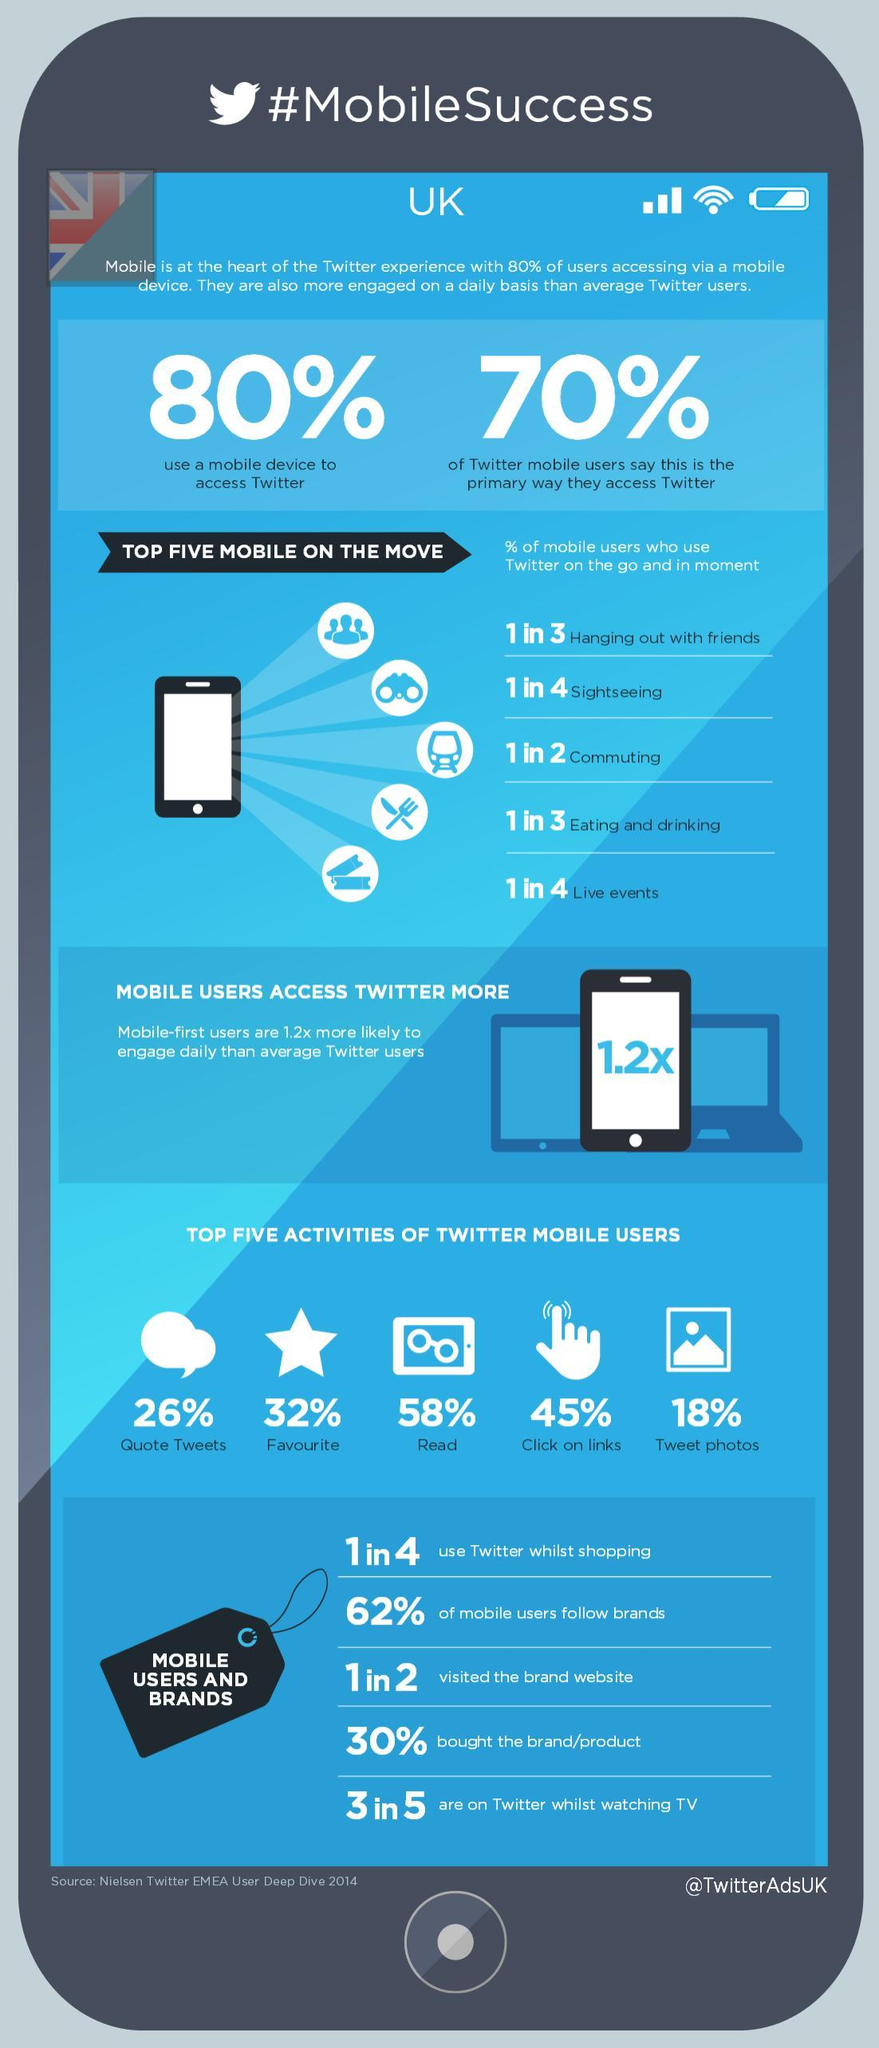What percent of mobile users do not follow brands?
Answer the question with a short phrase. 38% Which is the activity done by most Twitter mobile users? Read What is the Twitter handle given? @TwitterAdsUK 